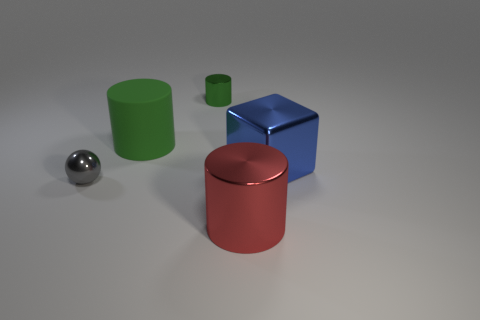Subtract 1 cylinders. How many cylinders are left? 2 Subtract all metallic cylinders. How many cylinders are left? 1 Add 1 tiny brown cylinders. How many objects exist? 6 Subtract all blocks. How many objects are left? 4 Subtract all gray balls. Subtract all green shiny objects. How many objects are left? 3 Add 5 small metal balls. How many small metal balls are left? 6 Add 4 big metallic cubes. How many big metallic cubes exist? 5 Subtract 0 green blocks. How many objects are left? 5 